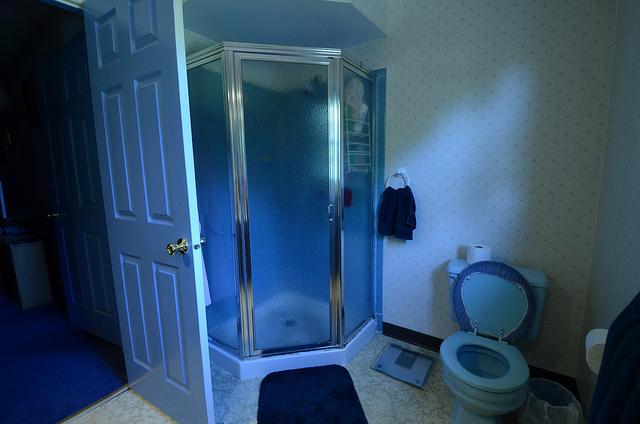Is the door on the left open or closed?
Concise answer only. Open. Is there a mirror in this room?
Short answer required. No. Is there a bath mat?
Give a very brief answer. Yes. What color is the Seat cover?
Write a very short answer. Blue. 